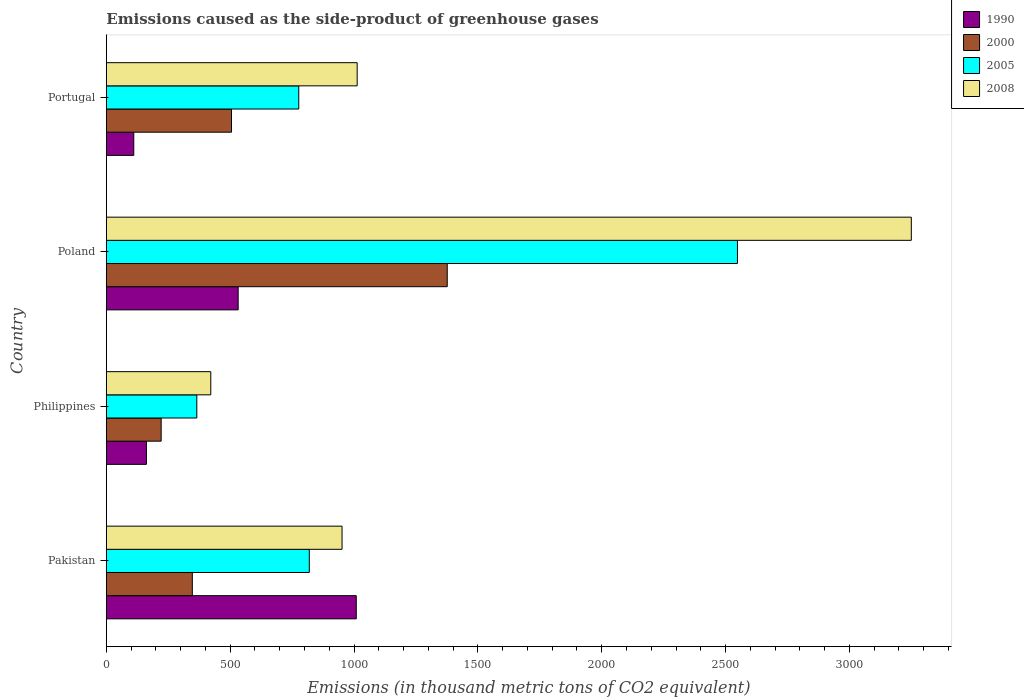How many groups of bars are there?
Give a very brief answer. 4. In how many cases, is the number of bars for a given country not equal to the number of legend labels?
Make the answer very short. 0. What is the emissions caused as the side-product of greenhouse gases in 2000 in Pakistan?
Ensure brevity in your answer.  347.2. Across all countries, what is the maximum emissions caused as the side-product of greenhouse gases in 1990?
Make the answer very short. 1009. Across all countries, what is the minimum emissions caused as the side-product of greenhouse gases in 2008?
Provide a succinct answer. 421.7. In which country was the emissions caused as the side-product of greenhouse gases in 1990 maximum?
Give a very brief answer. Pakistan. In which country was the emissions caused as the side-product of greenhouse gases in 1990 minimum?
Your answer should be compact. Portugal. What is the total emissions caused as the side-product of greenhouse gases in 2005 in the graph?
Provide a short and direct response. 4509.5. What is the difference between the emissions caused as the side-product of greenhouse gases in 1990 in Pakistan and that in Philippines?
Ensure brevity in your answer.  847.1. What is the difference between the emissions caused as the side-product of greenhouse gases in 2000 in Portugal and the emissions caused as the side-product of greenhouse gases in 2008 in Pakistan?
Offer a very short reply. -446.3. What is the average emissions caused as the side-product of greenhouse gases in 1990 per country?
Provide a succinct answer. 453.48. What is the difference between the emissions caused as the side-product of greenhouse gases in 2008 and emissions caused as the side-product of greenhouse gases in 2005 in Pakistan?
Give a very brief answer. 132.2. In how many countries, is the emissions caused as the side-product of greenhouse gases in 2005 greater than 200 thousand metric tons?
Ensure brevity in your answer.  4. What is the ratio of the emissions caused as the side-product of greenhouse gases in 1990 in Pakistan to that in Portugal?
Offer a very short reply. 9.11. What is the difference between the highest and the second highest emissions caused as the side-product of greenhouse gases in 2005?
Offer a very short reply. 1728.5. What is the difference between the highest and the lowest emissions caused as the side-product of greenhouse gases in 2000?
Keep it short and to the point. 1154.9. In how many countries, is the emissions caused as the side-product of greenhouse gases in 2005 greater than the average emissions caused as the side-product of greenhouse gases in 2005 taken over all countries?
Your answer should be compact. 1. Is it the case that in every country, the sum of the emissions caused as the side-product of greenhouse gases in 2005 and emissions caused as the side-product of greenhouse gases in 2000 is greater than the sum of emissions caused as the side-product of greenhouse gases in 2008 and emissions caused as the side-product of greenhouse gases in 1990?
Offer a very short reply. No. What does the 4th bar from the top in Poland represents?
Your answer should be compact. 1990. What does the 3rd bar from the bottom in Philippines represents?
Provide a succinct answer. 2005. Is it the case that in every country, the sum of the emissions caused as the side-product of greenhouse gases in 2008 and emissions caused as the side-product of greenhouse gases in 2005 is greater than the emissions caused as the side-product of greenhouse gases in 2000?
Offer a terse response. Yes. How many countries are there in the graph?
Offer a terse response. 4. Does the graph contain grids?
Ensure brevity in your answer.  No. How many legend labels are there?
Keep it short and to the point. 4. How are the legend labels stacked?
Offer a terse response. Vertical. What is the title of the graph?
Offer a very short reply. Emissions caused as the side-product of greenhouse gases. Does "1993" appear as one of the legend labels in the graph?
Your response must be concise. No. What is the label or title of the X-axis?
Give a very brief answer. Emissions (in thousand metric tons of CO2 equivalent). What is the label or title of the Y-axis?
Provide a short and direct response. Country. What is the Emissions (in thousand metric tons of CO2 equivalent) in 1990 in Pakistan?
Provide a short and direct response. 1009. What is the Emissions (in thousand metric tons of CO2 equivalent) in 2000 in Pakistan?
Provide a succinct answer. 347.2. What is the Emissions (in thousand metric tons of CO2 equivalent) of 2005 in Pakistan?
Keep it short and to the point. 819.4. What is the Emissions (in thousand metric tons of CO2 equivalent) of 2008 in Pakistan?
Offer a very short reply. 951.6. What is the Emissions (in thousand metric tons of CO2 equivalent) of 1990 in Philippines?
Make the answer very short. 161.9. What is the Emissions (in thousand metric tons of CO2 equivalent) in 2000 in Philippines?
Your answer should be very brief. 221.4. What is the Emissions (in thousand metric tons of CO2 equivalent) in 2005 in Philippines?
Make the answer very short. 365.3. What is the Emissions (in thousand metric tons of CO2 equivalent) in 2008 in Philippines?
Make the answer very short. 421.7. What is the Emissions (in thousand metric tons of CO2 equivalent) in 1990 in Poland?
Offer a very short reply. 532.2. What is the Emissions (in thousand metric tons of CO2 equivalent) of 2000 in Poland?
Provide a succinct answer. 1376.3. What is the Emissions (in thousand metric tons of CO2 equivalent) in 2005 in Poland?
Provide a short and direct response. 2547.9. What is the Emissions (in thousand metric tons of CO2 equivalent) of 2008 in Poland?
Offer a terse response. 3249.8. What is the Emissions (in thousand metric tons of CO2 equivalent) in 1990 in Portugal?
Your answer should be very brief. 110.8. What is the Emissions (in thousand metric tons of CO2 equivalent) in 2000 in Portugal?
Your answer should be compact. 505.3. What is the Emissions (in thousand metric tons of CO2 equivalent) in 2005 in Portugal?
Your answer should be very brief. 776.9. What is the Emissions (in thousand metric tons of CO2 equivalent) in 2008 in Portugal?
Your answer should be compact. 1012.7. Across all countries, what is the maximum Emissions (in thousand metric tons of CO2 equivalent) of 1990?
Your answer should be very brief. 1009. Across all countries, what is the maximum Emissions (in thousand metric tons of CO2 equivalent) in 2000?
Make the answer very short. 1376.3. Across all countries, what is the maximum Emissions (in thousand metric tons of CO2 equivalent) of 2005?
Keep it short and to the point. 2547.9. Across all countries, what is the maximum Emissions (in thousand metric tons of CO2 equivalent) of 2008?
Your answer should be compact. 3249.8. Across all countries, what is the minimum Emissions (in thousand metric tons of CO2 equivalent) of 1990?
Offer a terse response. 110.8. Across all countries, what is the minimum Emissions (in thousand metric tons of CO2 equivalent) in 2000?
Provide a succinct answer. 221.4. Across all countries, what is the minimum Emissions (in thousand metric tons of CO2 equivalent) of 2005?
Provide a succinct answer. 365.3. Across all countries, what is the minimum Emissions (in thousand metric tons of CO2 equivalent) in 2008?
Offer a very short reply. 421.7. What is the total Emissions (in thousand metric tons of CO2 equivalent) of 1990 in the graph?
Offer a very short reply. 1813.9. What is the total Emissions (in thousand metric tons of CO2 equivalent) of 2000 in the graph?
Give a very brief answer. 2450.2. What is the total Emissions (in thousand metric tons of CO2 equivalent) of 2005 in the graph?
Give a very brief answer. 4509.5. What is the total Emissions (in thousand metric tons of CO2 equivalent) of 2008 in the graph?
Your answer should be very brief. 5635.8. What is the difference between the Emissions (in thousand metric tons of CO2 equivalent) of 1990 in Pakistan and that in Philippines?
Offer a terse response. 847.1. What is the difference between the Emissions (in thousand metric tons of CO2 equivalent) of 2000 in Pakistan and that in Philippines?
Ensure brevity in your answer.  125.8. What is the difference between the Emissions (in thousand metric tons of CO2 equivalent) of 2005 in Pakistan and that in Philippines?
Your answer should be compact. 454.1. What is the difference between the Emissions (in thousand metric tons of CO2 equivalent) of 2008 in Pakistan and that in Philippines?
Your answer should be compact. 529.9. What is the difference between the Emissions (in thousand metric tons of CO2 equivalent) in 1990 in Pakistan and that in Poland?
Offer a terse response. 476.8. What is the difference between the Emissions (in thousand metric tons of CO2 equivalent) in 2000 in Pakistan and that in Poland?
Ensure brevity in your answer.  -1029.1. What is the difference between the Emissions (in thousand metric tons of CO2 equivalent) in 2005 in Pakistan and that in Poland?
Your answer should be very brief. -1728.5. What is the difference between the Emissions (in thousand metric tons of CO2 equivalent) of 2008 in Pakistan and that in Poland?
Your answer should be compact. -2298.2. What is the difference between the Emissions (in thousand metric tons of CO2 equivalent) of 1990 in Pakistan and that in Portugal?
Keep it short and to the point. 898.2. What is the difference between the Emissions (in thousand metric tons of CO2 equivalent) in 2000 in Pakistan and that in Portugal?
Provide a succinct answer. -158.1. What is the difference between the Emissions (in thousand metric tons of CO2 equivalent) in 2005 in Pakistan and that in Portugal?
Your response must be concise. 42.5. What is the difference between the Emissions (in thousand metric tons of CO2 equivalent) in 2008 in Pakistan and that in Portugal?
Ensure brevity in your answer.  -61.1. What is the difference between the Emissions (in thousand metric tons of CO2 equivalent) of 1990 in Philippines and that in Poland?
Make the answer very short. -370.3. What is the difference between the Emissions (in thousand metric tons of CO2 equivalent) in 2000 in Philippines and that in Poland?
Ensure brevity in your answer.  -1154.9. What is the difference between the Emissions (in thousand metric tons of CO2 equivalent) of 2005 in Philippines and that in Poland?
Your response must be concise. -2182.6. What is the difference between the Emissions (in thousand metric tons of CO2 equivalent) in 2008 in Philippines and that in Poland?
Your response must be concise. -2828.1. What is the difference between the Emissions (in thousand metric tons of CO2 equivalent) in 1990 in Philippines and that in Portugal?
Keep it short and to the point. 51.1. What is the difference between the Emissions (in thousand metric tons of CO2 equivalent) of 2000 in Philippines and that in Portugal?
Provide a short and direct response. -283.9. What is the difference between the Emissions (in thousand metric tons of CO2 equivalent) of 2005 in Philippines and that in Portugal?
Your answer should be very brief. -411.6. What is the difference between the Emissions (in thousand metric tons of CO2 equivalent) in 2008 in Philippines and that in Portugal?
Keep it short and to the point. -591. What is the difference between the Emissions (in thousand metric tons of CO2 equivalent) of 1990 in Poland and that in Portugal?
Your answer should be very brief. 421.4. What is the difference between the Emissions (in thousand metric tons of CO2 equivalent) in 2000 in Poland and that in Portugal?
Offer a terse response. 871. What is the difference between the Emissions (in thousand metric tons of CO2 equivalent) in 2005 in Poland and that in Portugal?
Give a very brief answer. 1771. What is the difference between the Emissions (in thousand metric tons of CO2 equivalent) in 2008 in Poland and that in Portugal?
Provide a succinct answer. 2237.1. What is the difference between the Emissions (in thousand metric tons of CO2 equivalent) of 1990 in Pakistan and the Emissions (in thousand metric tons of CO2 equivalent) of 2000 in Philippines?
Provide a succinct answer. 787.6. What is the difference between the Emissions (in thousand metric tons of CO2 equivalent) in 1990 in Pakistan and the Emissions (in thousand metric tons of CO2 equivalent) in 2005 in Philippines?
Your response must be concise. 643.7. What is the difference between the Emissions (in thousand metric tons of CO2 equivalent) of 1990 in Pakistan and the Emissions (in thousand metric tons of CO2 equivalent) of 2008 in Philippines?
Your response must be concise. 587.3. What is the difference between the Emissions (in thousand metric tons of CO2 equivalent) in 2000 in Pakistan and the Emissions (in thousand metric tons of CO2 equivalent) in 2005 in Philippines?
Offer a terse response. -18.1. What is the difference between the Emissions (in thousand metric tons of CO2 equivalent) in 2000 in Pakistan and the Emissions (in thousand metric tons of CO2 equivalent) in 2008 in Philippines?
Keep it short and to the point. -74.5. What is the difference between the Emissions (in thousand metric tons of CO2 equivalent) in 2005 in Pakistan and the Emissions (in thousand metric tons of CO2 equivalent) in 2008 in Philippines?
Your answer should be compact. 397.7. What is the difference between the Emissions (in thousand metric tons of CO2 equivalent) in 1990 in Pakistan and the Emissions (in thousand metric tons of CO2 equivalent) in 2000 in Poland?
Make the answer very short. -367.3. What is the difference between the Emissions (in thousand metric tons of CO2 equivalent) of 1990 in Pakistan and the Emissions (in thousand metric tons of CO2 equivalent) of 2005 in Poland?
Your answer should be compact. -1538.9. What is the difference between the Emissions (in thousand metric tons of CO2 equivalent) of 1990 in Pakistan and the Emissions (in thousand metric tons of CO2 equivalent) of 2008 in Poland?
Offer a terse response. -2240.8. What is the difference between the Emissions (in thousand metric tons of CO2 equivalent) in 2000 in Pakistan and the Emissions (in thousand metric tons of CO2 equivalent) in 2005 in Poland?
Give a very brief answer. -2200.7. What is the difference between the Emissions (in thousand metric tons of CO2 equivalent) of 2000 in Pakistan and the Emissions (in thousand metric tons of CO2 equivalent) of 2008 in Poland?
Provide a short and direct response. -2902.6. What is the difference between the Emissions (in thousand metric tons of CO2 equivalent) of 2005 in Pakistan and the Emissions (in thousand metric tons of CO2 equivalent) of 2008 in Poland?
Give a very brief answer. -2430.4. What is the difference between the Emissions (in thousand metric tons of CO2 equivalent) in 1990 in Pakistan and the Emissions (in thousand metric tons of CO2 equivalent) in 2000 in Portugal?
Give a very brief answer. 503.7. What is the difference between the Emissions (in thousand metric tons of CO2 equivalent) in 1990 in Pakistan and the Emissions (in thousand metric tons of CO2 equivalent) in 2005 in Portugal?
Your response must be concise. 232.1. What is the difference between the Emissions (in thousand metric tons of CO2 equivalent) of 2000 in Pakistan and the Emissions (in thousand metric tons of CO2 equivalent) of 2005 in Portugal?
Keep it short and to the point. -429.7. What is the difference between the Emissions (in thousand metric tons of CO2 equivalent) of 2000 in Pakistan and the Emissions (in thousand metric tons of CO2 equivalent) of 2008 in Portugal?
Give a very brief answer. -665.5. What is the difference between the Emissions (in thousand metric tons of CO2 equivalent) in 2005 in Pakistan and the Emissions (in thousand metric tons of CO2 equivalent) in 2008 in Portugal?
Provide a succinct answer. -193.3. What is the difference between the Emissions (in thousand metric tons of CO2 equivalent) in 1990 in Philippines and the Emissions (in thousand metric tons of CO2 equivalent) in 2000 in Poland?
Provide a short and direct response. -1214.4. What is the difference between the Emissions (in thousand metric tons of CO2 equivalent) in 1990 in Philippines and the Emissions (in thousand metric tons of CO2 equivalent) in 2005 in Poland?
Provide a succinct answer. -2386. What is the difference between the Emissions (in thousand metric tons of CO2 equivalent) in 1990 in Philippines and the Emissions (in thousand metric tons of CO2 equivalent) in 2008 in Poland?
Offer a terse response. -3087.9. What is the difference between the Emissions (in thousand metric tons of CO2 equivalent) in 2000 in Philippines and the Emissions (in thousand metric tons of CO2 equivalent) in 2005 in Poland?
Ensure brevity in your answer.  -2326.5. What is the difference between the Emissions (in thousand metric tons of CO2 equivalent) in 2000 in Philippines and the Emissions (in thousand metric tons of CO2 equivalent) in 2008 in Poland?
Ensure brevity in your answer.  -3028.4. What is the difference between the Emissions (in thousand metric tons of CO2 equivalent) of 2005 in Philippines and the Emissions (in thousand metric tons of CO2 equivalent) of 2008 in Poland?
Ensure brevity in your answer.  -2884.5. What is the difference between the Emissions (in thousand metric tons of CO2 equivalent) in 1990 in Philippines and the Emissions (in thousand metric tons of CO2 equivalent) in 2000 in Portugal?
Provide a succinct answer. -343.4. What is the difference between the Emissions (in thousand metric tons of CO2 equivalent) in 1990 in Philippines and the Emissions (in thousand metric tons of CO2 equivalent) in 2005 in Portugal?
Provide a succinct answer. -615. What is the difference between the Emissions (in thousand metric tons of CO2 equivalent) in 1990 in Philippines and the Emissions (in thousand metric tons of CO2 equivalent) in 2008 in Portugal?
Ensure brevity in your answer.  -850.8. What is the difference between the Emissions (in thousand metric tons of CO2 equivalent) of 2000 in Philippines and the Emissions (in thousand metric tons of CO2 equivalent) of 2005 in Portugal?
Provide a short and direct response. -555.5. What is the difference between the Emissions (in thousand metric tons of CO2 equivalent) of 2000 in Philippines and the Emissions (in thousand metric tons of CO2 equivalent) of 2008 in Portugal?
Make the answer very short. -791.3. What is the difference between the Emissions (in thousand metric tons of CO2 equivalent) in 2005 in Philippines and the Emissions (in thousand metric tons of CO2 equivalent) in 2008 in Portugal?
Keep it short and to the point. -647.4. What is the difference between the Emissions (in thousand metric tons of CO2 equivalent) of 1990 in Poland and the Emissions (in thousand metric tons of CO2 equivalent) of 2000 in Portugal?
Your response must be concise. 26.9. What is the difference between the Emissions (in thousand metric tons of CO2 equivalent) of 1990 in Poland and the Emissions (in thousand metric tons of CO2 equivalent) of 2005 in Portugal?
Keep it short and to the point. -244.7. What is the difference between the Emissions (in thousand metric tons of CO2 equivalent) in 1990 in Poland and the Emissions (in thousand metric tons of CO2 equivalent) in 2008 in Portugal?
Offer a terse response. -480.5. What is the difference between the Emissions (in thousand metric tons of CO2 equivalent) of 2000 in Poland and the Emissions (in thousand metric tons of CO2 equivalent) of 2005 in Portugal?
Keep it short and to the point. 599.4. What is the difference between the Emissions (in thousand metric tons of CO2 equivalent) of 2000 in Poland and the Emissions (in thousand metric tons of CO2 equivalent) of 2008 in Portugal?
Make the answer very short. 363.6. What is the difference between the Emissions (in thousand metric tons of CO2 equivalent) in 2005 in Poland and the Emissions (in thousand metric tons of CO2 equivalent) in 2008 in Portugal?
Ensure brevity in your answer.  1535.2. What is the average Emissions (in thousand metric tons of CO2 equivalent) of 1990 per country?
Give a very brief answer. 453.48. What is the average Emissions (in thousand metric tons of CO2 equivalent) of 2000 per country?
Your answer should be compact. 612.55. What is the average Emissions (in thousand metric tons of CO2 equivalent) of 2005 per country?
Provide a short and direct response. 1127.38. What is the average Emissions (in thousand metric tons of CO2 equivalent) of 2008 per country?
Offer a terse response. 1408.95. What is the difference between the Emissions (in thousand metric tons of CO2 equivalent) in 1990 and Emissions (in thousand metric tons of CO2 equivalent) in 2000 in Pakistan?
Ensure brevity in your answer.  661.8. What is the difference between the Emissions (in thousand metric tons of CO2 equivalent) of 1990 and Emissions (in thousand metric tons of CO2 equivalent) of 2005 in Pakistan?
Ensure brevity in your answer.  189.6. What is the difference between the Emissions (in thousand metric tons of CO2 equivalent) in 1990 and Emissions (in thousand metric tons of CO2 equivalent) in 2008 in Pakistan?
Offer a very short reply. 57.4. What is the difference between the Emissions (in thousand metric tons of CO2 equivalent) in 2000 and Emissions (in thousand metric tons of CO2 equivalent) in 2005 in Pakistan?
Keep it short and to the point. -472.2. What is the difference between the Emissions (in thousand metric tons of CO2 equivalent) of 2000 and Emissions (in thousand metric tons of CO2 equivalent) of 2008 in Pakistan?
Your answer should be compact. -604.4. What is the difference between the Emissions (in thousand metric tons of CO2 equivalent) in 2005 and Emissions (in thousand metric tons of CO2 equivalent) in 2008 in Pakistan?
Your answer should be very brief. -132.2. What is the difference between the Emissions (in thousand metric tons of CO2 equivalent) of 1990 and Emissions (in thousand metric tons of CO2 equivalent) of 2000 in Philippines?
Your answer should be very brief. -59.5. What is the difference between the Emissions (in thousand metric tons of CO2 equivalent) of 1990 and Emissions (in thousand metric tons of CO2 equivalent) of 2005 in Philippines?
Make the answer very short. -203.4. What is the difference between the Emissions (in thousand metric tons of CO2 equivalent) in 1990 and Emissions (in thousand metric tons of CO2 equivalent) in 2008 in Philippines?
Give a very brief answer. -259.8. What is the difference between the Emissions (in thousand metric tons of CO2 equivalent) of 2000 and Emissions (in thousand metric tons of CO2 equivalent) of 2005 in Philippines?
Your answer should be very brief. -143.9. What is the difference between the Emissions (in thousand metric tons of CO2 equivalent) in 2000 and Emissions (in thousand metric tons of CO2 equivalent) in 2008 in Philippines?
Make the answer very short. -200.3. What is the difference between the Emissions (in thousand metric tons of CO2 equivalent) of 2005 and Emissions (in thousand metric tons of CO2 equivalent) of 2008 in Philippines?
Ensure brevity in your answer.  -56.4. What is the difference between the Emissions (in thousand metric tons of CO2 equivalent) in 1990 and Emissions (in thousand metric tons of CO2 equivalent) in 2000 in Poland?
Provide a short and direct response. -844.1. What is the difference between the Emissions (in thousand metric tons of CO2 equivalent) of 1990 and Emissions (in thousand metric tons of CO2 equivalent) of 2005 in Poland?
Keep it short and to the point. -2015.7. What is the difference between the Emissions (in thousand metric tons of CO2 equivalent) of 1990 and Emissions (in thousand metric tons of CO2 equivalent) of 2008 in Poland?
Your response must be concise. -2717.6. What is the difference between the Emissions (in thousand metric tons of CO2 equivalent) in 2000 and Emissions (in thousand metric tons of CO2 equivalent) in 2005 in Poland?
Your answer should be compact. -1171.6. What is the difference between the Emissions (in thousand metric tons of CO2 equivalent) of 2000 and Emissions (in thousand metric tons of CO2 equivalent) of 2008 in Poland?
Provide a succinct answer. -1873.5. What is the difference between the Emissions (in thousand metric tons of CO2 equivalent) in 2005 and Emissions (in thousand metric tons of CO2 equivalent) in 2008 in Poland?
Make the answer very short. -701.9. What is the difference between the Emissions (in thousand metric tons of CO2 equivalent) in 1990 and Emissions (in thousand metric tons of CO2 equivalent) in 2000 in Portugal?
Provide a short and direct response. -394.5. What is the difference between the Emissions (in thousand metric tons of CO2 equivalent) of 1990 and Emissions (in thousand metric tons of CO2 equivalent) of 2005 in Portugal?
Offer a very short reply. -666.1. What is the difference between the Emissions (in thousand metric tons of CO2 equivalent) of 1990 and Emissions (in thousand metric tons of CO2 equivalent) of 2008 in Portugal?
Offer a very short reply. -901.9. What is the difference between the Emissions (in thousand metric tons of CO2 equivalent) of 2000 and Emissions (in thousand metric tons of CO2 equivalent) of 2005 in Portugal?
Ensure brevity in your answer.  -271.6. What is the difference between the Emissions (in thousand metric tons of CO2 equivalent) in 2000 and Emissions (in thousand metric tons of CO2 equivalent) in 2008 in Portugal?
Give a very brief answer. -507.4. What is the difference between the Emissions (in thousand metric tons of CO2 equivalent) in 2005 and Emissions (in thousand metric tons of CO2 equivalent) in 2008 in Portugal?
Make the answer very short. -235.8. What is the ratio of the Emissions (in thousand metric tons of CO2 equivalent) in 1990 in Pakistan to that in Philippines?
Your answer should be very brief. 6.23. What is the ratio of the Emissions (in thousand metric tons of CO2 equivalent) in 2000 in Pakistan to that in Philippines?
Your answer should be very brief. 1.57. What is the ratio of the Emissions (in thousand metric tons of CO2 equivalent) in 2005 in Pakistan to that in Philippines?
Give a very brief answer. 2.24. What is the ratio of the Emissions (in thousand metric tons of CO2 equivalent) of 2008 in Pakistan to that in Philippines?
Make the answer very short. 2.26. What is the ratio of the Emissions (in thousand metric tons of CO2 equivalent) in 1990 in Pakistan to that in Poland?
Give a very brief answer. 1.9. What is the ratio of the Emissions (in thousand metric tons of CO2 equivalent) in 2000 in Pakistan to that in Poland?
Give a very brief answer. 0.25. What is the ratio of the Emissions (in thousand metric tons of CO2 equivalent) in 2005 in Pakistan to that in Poland?
Your response must be concise. 0.32. What is the ratio of the Emissions (in thousand metric tons of CO2 equivalent) of 2008 in Pakistan to that in Poland?
Provide a succinct answer. 0.29. What is the ratio of the Emissions (in thousand metric tons of CO2 equivalent) of 1990 in Pakistan to that in Portugal?
Offer a terse response. 9.11. What is the ratio of the Emissions (in thousand metric tons of CO2 equivalent) of 2000 in Pakistan to that in Portugal?
Offer a very short reply. 0.69. What is the ratio of the Emissions (in thousand metric tons of CO2 equivalent) of 2005 in Pakistan to that in Portugal?
Keep it short and to the point. 1.05. What is the ratio of the Emissions (in thousand metric tons of CO2 equivalent) of 2008 in Pakistan to that in Portugal?
Provide a succinct answer. 0.94. What is the ratio of the Emissions (in thousand metric tons of CO2 equivalent) of 1990 in Philippines to that in Poland?
Make the answer very short. 0.3. What is the ratio of the Emissions (in thousand metric tons of CO2 equivalent) of 2000 in Philippines to that in Poland?
Your answer should be very brief. 0.16. What is the ratio of the Emissions (in thousand metric tons of CO2 equivalent) of 2005 in Philippines to that in Poland?
Offer a very short reply. 0.14. What is the ratio of the Emissions (in thousand metric tons of CO2 equivalent) in 2008 in Philippines to that in Poland?
Provide a succinct answer. 0.13. What is the ratio of the Emissions (in thousand metric tons of CO2 equivalent) in 1990 in Philippines to that in Portugal?
Offer a terse response. 1.46. What is the ratio of the Emissions (in thousand metric tons of CO2 equivalent) of 2000 in Philippines to that in Portugal?
Your answer should be compact. 0.44. What is the ratio of the Emissions (in thousand metric tons of CO2 equivalent) of 2005 in Philippines to that in Portugal?
Provide a succinct answer. 0.47. What is the ratio of the Emissions (in thousand metric tons of CO2 equivalent) of 2008 in Philippines to that in Portugal?
Offer a terse response. 0.42. What is the ratio of the Emissions (in thousand metric tons of CO2 equivalent) of 1990 in Poland to that in Portugal?
Give a very brief answer. 4.8. What is the ratio of the Emissions (in thousand metric tons of CO2 equivalent) in 2000 in Poland to that in Portugal?
Offer a terse response. 2.72. What is the ratio of the Emissions (in thousand metric tons of CO2 equivalent) of 2005 in Poland to that in Portugal?
Provide a short and direct response. 3.28. What is the ratio of the Emissions (in thousand metric tons of CO2 equivalent) of 2008 in Poland to that in Portugal?
Your answer should be compact. 3.21. What is the difference between the highest and the second highest Emissions (in thousand metric tons of CO2 equivalent) of 1990?
Your answer should be compact. 476.8. What is the difference between the highest and the second highest Emissions (in thousand metric tons of CO2 equivalent) in 2000?
Provide a succinct answer. 871. What is the difference between the highest and the second highest Emissions (in thousand metric tons of CO2 equivalent) in 2005?
Ensure brevity in your answer.  1728.5. What is the difference between the highest and the second highest Emissions (in thousand metric tons of CO2 equivalent) of 2008?
Your answer should be compact. 2237.1. What is the difference between the highest and the lowest Emissions (in thousand metric tons of CO2 equivalent) of 1990?
Provide a succinct answer. 898.2. What is the difference between the highest and the lowest Emissions (in thousand metric tons of CO2 equivalent) of 2000?
Make the answer very short. 1154.9. What is the difference between the highest and the lowest Emissions (in thousand metric tons of CO2 equivalent) in 2005?
Offer a very short reply. 2182.6. What is the difference between the highest and the lowest Emissions (in thousand metric tons of CO2 equivalent) in 2008?
Offer a very short reply. 2828.1. 